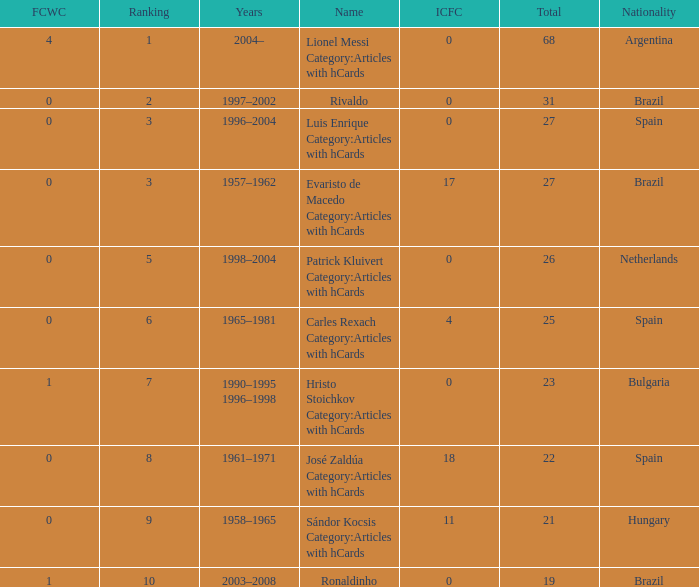What is the lowest ranking associated with a total of 23? 7.0. 